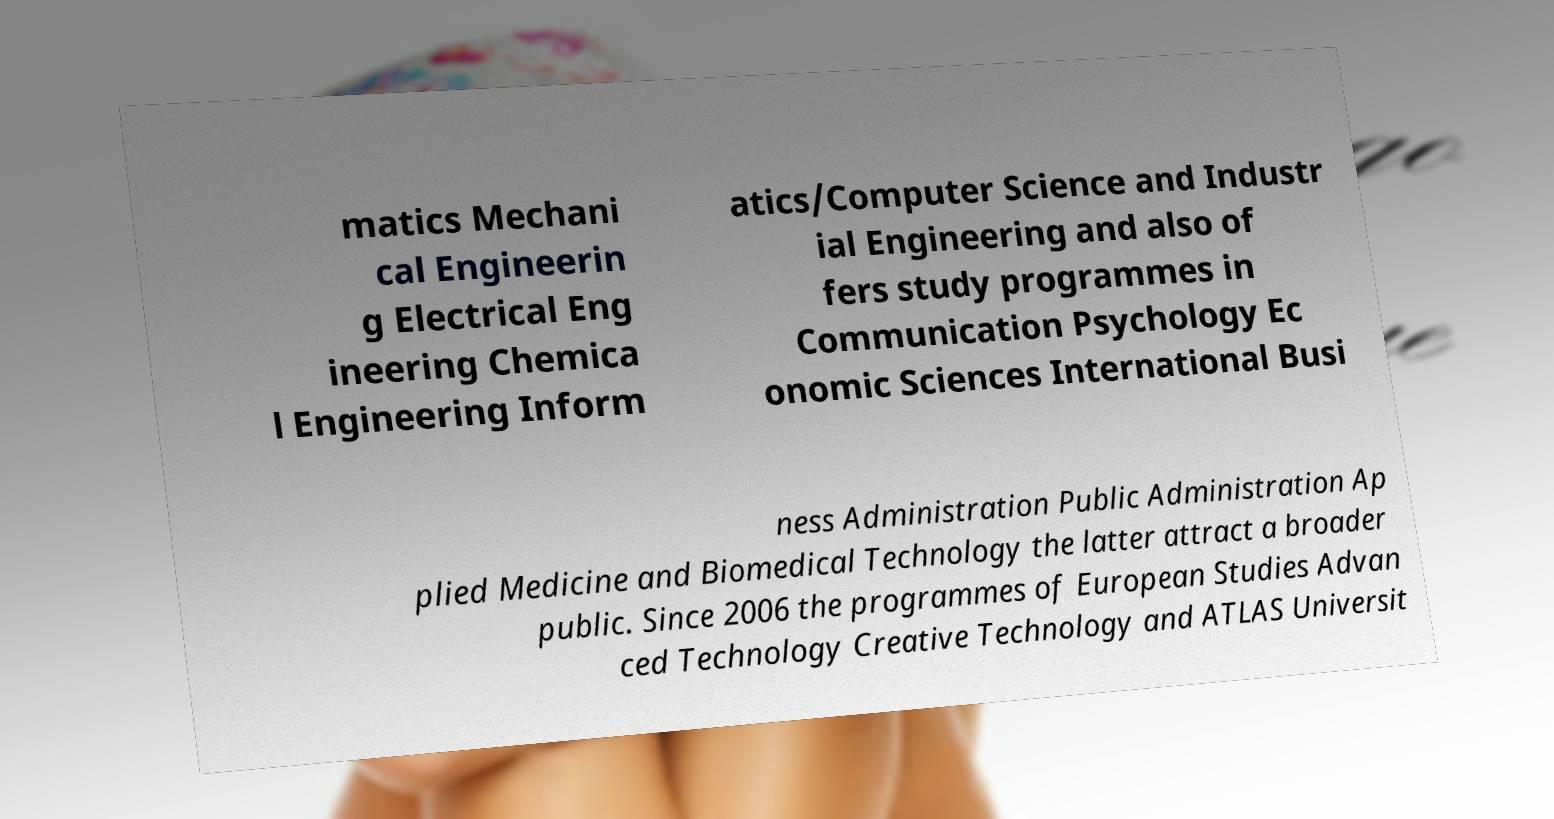There's text embedded in this image that I need extracted. Can you transcribe it verbatim? matics Mechani cal Engineerin g Electrical Eng ineering Chemica l Engineering Inform atics/Computer Science and Industr ial Engineering and also of fers study programmes in Communication Psychology Ec onomic Sciences International Busi ness Administration Public Administration Ap plied Medicine and Biomedical Technology the latter attract a broader public. Since 2006 the programmes of European Studies Advan ced Technology Creative Technology and ATLAS Universit 